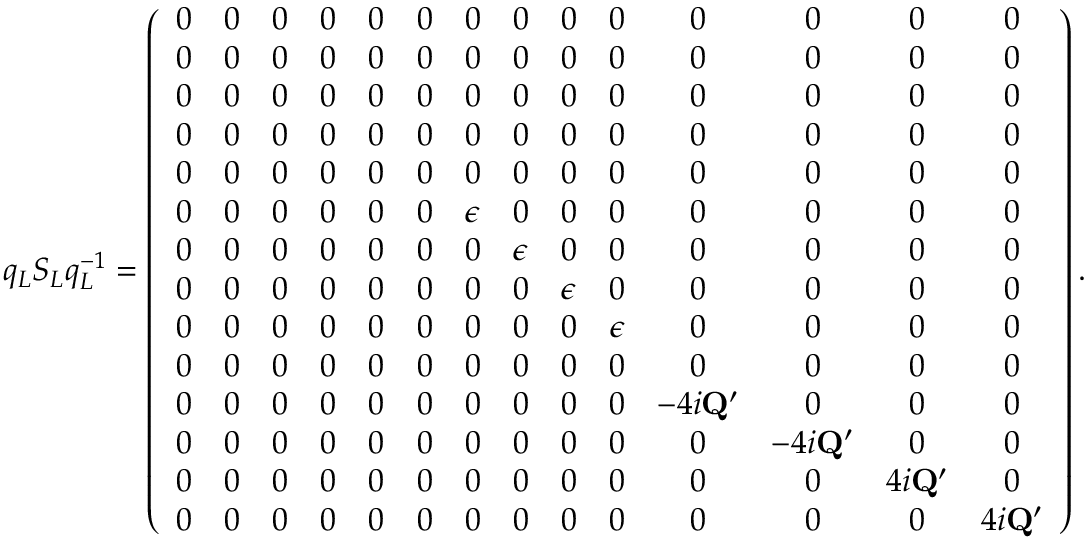Convert formula to latex. <formula><loc_0><loc_0><loc_500><loc_500>q _ { L } S _ { L } q _ { L } ^ { - 1 } = \left ( \begin{array} { c c c c c c c c c c c c c c } { 0 } & { 0 } & { 0 } & { 0 } & { 0 } & { 0 } & { 0 } & { 0 } & { 0 } & { 0 } & { 0 } & { 0 } & { 0 } & { 0 } \\ { 0 } & { 0 } & { 0 } & { 0 } & { 0 } & { 0 } & { 0 } & { 0 } & { 0 } & { 0 } & { 0 } & { 0 } & { 0 } & { 0 } \\ { 0 } & { 0 } & { 0 } & { 0 } & { 0 } & { 0 } & { 0 } & { 0 } & { 0 } & { 0 } & { 0 } & { 0 } & { 0 } & { 0 } \\ { 0 } & { 0 } & { 0 } & { 0 } & { 0 } & { 0 } & { 0 } & { 0 } & { 0 } & { 0 } & { 0 } & { 0 } & { 0 } & { 0 } \\ { 0 } & { 0 } & { 0 } & { 0 } & { 0 } & { 0 } & { 0 } & { 0 } & { 0 } & { 0 } & { 0 } & { 0 } & { 0 } & { 0 } \\ { 0 } & { 0 } & { 0 } & { 0 } & { 0 } & { 0 } & { \epsilon } & { 0 } & { 0 } & { 0 } & { 0 } & { 0 } & { 0 } & { 0 } \\ { 0 } & { 0 } & { 0 } & { 0 } & { 0 } & { 0 } & { 0 } & { \epsilon } & { 0 } & { 0 } & { 0 } & { 0 } & { 0 } & { 0 } \\ { 0 } & { 0 } & { 0 } & { 0 } & { 0 } & { 0 } & { 0 } & { 0 } & { \epsilon } & { 0 } & { 0 } & { 0 } & { 0 } & { 0 } \\ { 0 } & { 0 } & { 0 } & { 0 } & { 0 } & { 0 } & { 0 } & { 0 } & { 0 } & { \epsilon } & { 0 } & { 0 } & { 0 } & { 0 } \\ { 0 } & { 0 } & { 0 } & { 0 } & { 0 } & { 0 } & { 0 } & { 0 } & { 0 } & { 0 } & { 0 } & { 0 } & { 0 } & { 0 } \\ { 0 } & { 0 } & { 0 } & { 0 } & { 0 } & { 0 } & { 0 } & { 0 } & { 0 } & { 0 } & { - 4 i Q ^ { \prime } } & { 0 } & { 0 } & { 0 } \\ { 0 } & { 0 } & { 0 } & { 0 } & { 0 } & { 0 } & { 0 } & { 0 } & { 0 } & { 0 } & { 0 } & { - 4 i Q ^ { \prime } } & { 0 } & { 0 } \\ { 0 } & { 0 } & { 0 } & { 0 } & { 0 } & { 0 } & { 0 } & { 0 } & { 0 } & { 0 } & { 0 } & { 0 } & { 4 i Q ^ { \prime } } & { 0 } \\ { 0 } & { 0 } & { 0 } & { 0 } & { 0 } & { 0 } & { 0 } & { 0 } & { 0 } & { 0 } & { 0 } & { 0 } & { 0 } & { 4 i Q ^ { \prime } } \end{array} \right ) .</formula> 